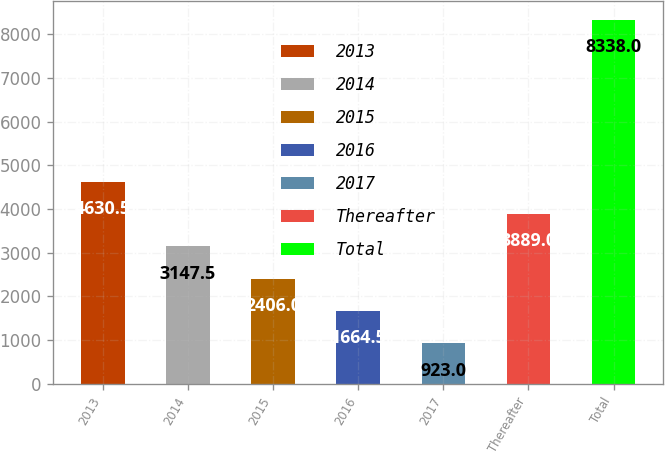Convert chart to OTSL. <chart><loc_0><loc_0><loc_500><loc_500><bar_chart><fcel>2013<fcel>2014<fcel>2015<fcel>2016<fcel>2017<fcel>Thereafter<fcel>Total<nl><fcel>4630.5<fcel>3147.5<fcel>2406<fcel>1664.5<fcel>923<fcel>3889<fcel>8338<nl></chart> 